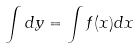<formula> <loc_0><loc_0><loc_500><loc_500>\int d y = \int f ( x ) d x</formula> 